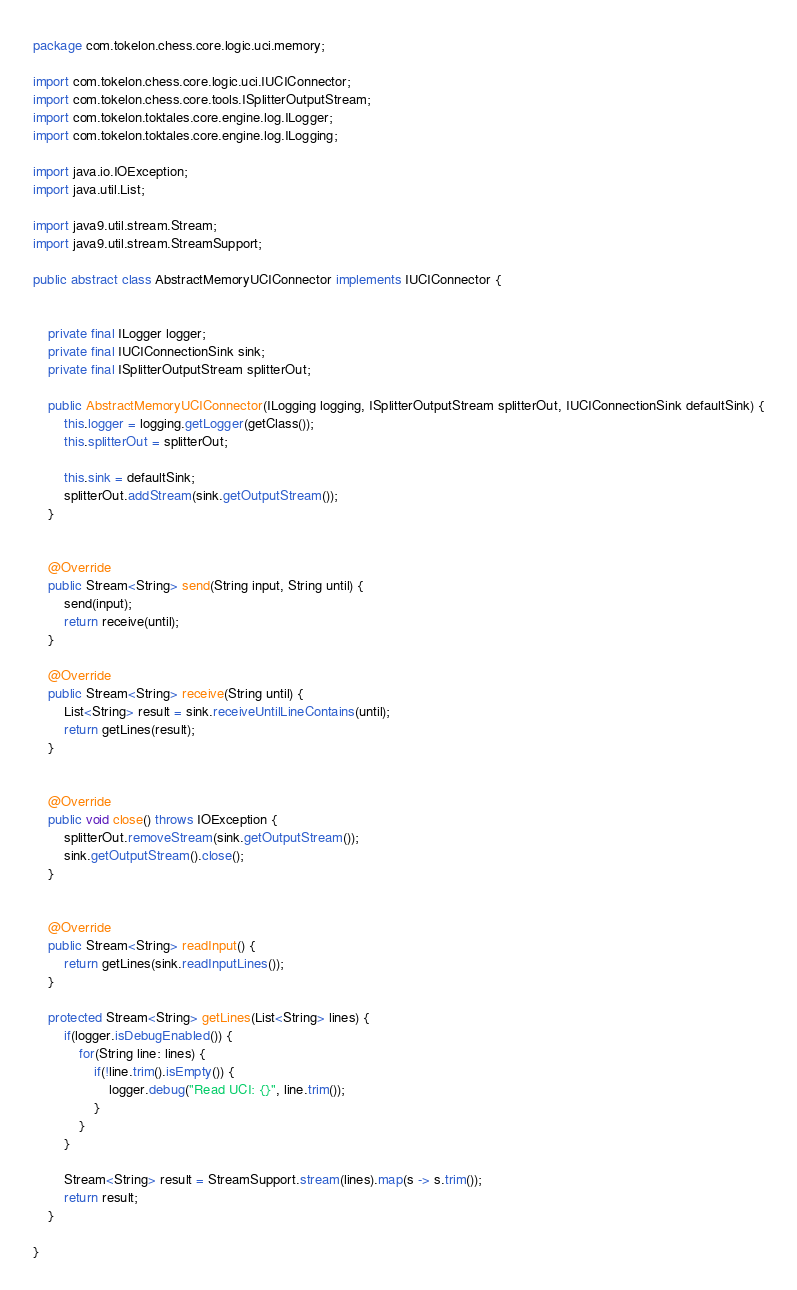Convert code to text. <code><loc_0><loc_0><loc_500><loc_500><_Java_>package com.tokelon.chess.core.logic.uci.memory;

import com.tokelon.chess.core.logic.uci.IUCIConnector;
import com.tokelon.chess.core.tools.ISplitterOutputStream;
import com.tokelon.toktales.core.engine.log.ILogger;
import com.tokelon.toktales.core.engine.log.ILogging;

import java.io.IOException;
import java.util.List;

import java9.util.stream.Stream;
import java9.util.stream.StreamSupport;

public abstract class AbstractMemoryUCIConnector implements IUCIConnector {


    private final ILogger logger;
    private final IUCIConnectionSink sink;
    private final ISplitterOutputStream splitterOut;

    public AbstractMemoryUCIConnector(ILogging logging, ISplitterOutputStream splitterOut, IUCIConnectionSink defaultSink) {
        this.logger = logging.getLogger(getClass());
        this.splitterOut = splitterOut;

        this.sink = defaultSink;
        splitterOut.addStream(sink.getOutputStream());
    }


    @Override
    public Stream<String> send(String input, String until) {
        send(input);
        return receive(until);
    }

    @Override
    public Stream<String> receive(String until) {
        List<String> result = sink.receiveUntilLineContains(until);
        return getLines(result);
    }


    @Override
    public void close() throws IOException {
        splitterOut.removeStream(sink.getOutputStream());
        sink.getOutputStream().close();
    }


    @Override
    public Stream<String> readInput() {
        return getLines(sink.readInputLines());
    }

    protected Stream<String> getLines(List<String> lines) {
        if(logger.isDebugEnabled()) {
            for(String line: lines) {
                if(!line.trim().isEmpty()) {
                    logger.debug("Read UCI: {}", line.trim());
                }
            }
        }

        Stream<String> result = StreamSupport.stream(lines).map(s -> s.trim());
        return result;
    }

}
</code> 